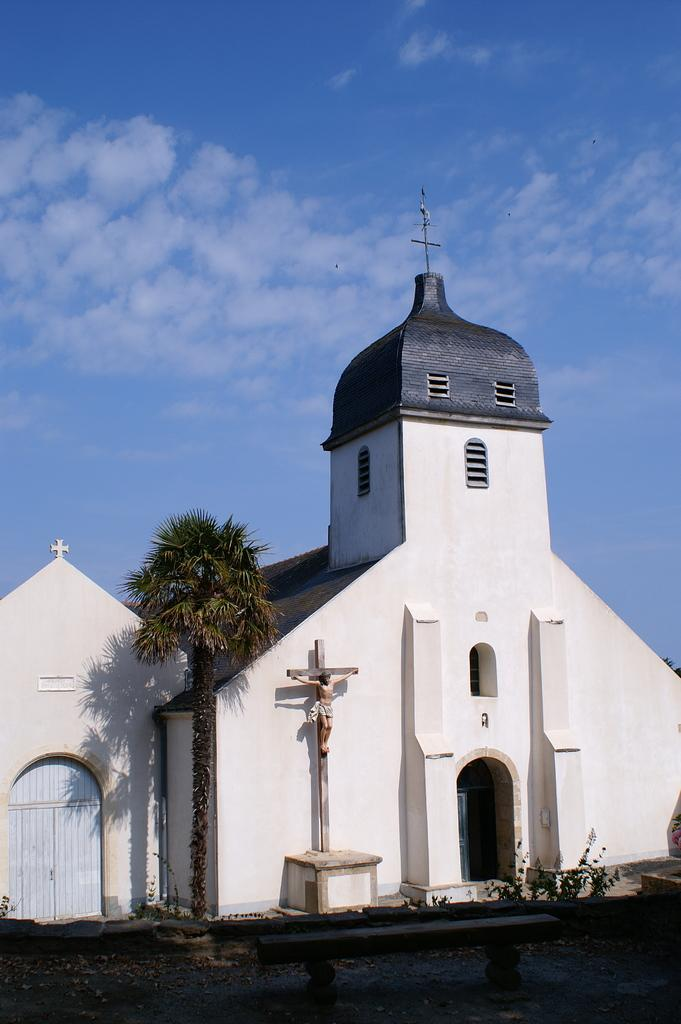What is the main subject of the image? There is a church in the center of the image. Can you describe the church in the image? The church is the main subject, and it is located in the center of the image. Are there any other notable features or objects in the image? The provided facts do not mention any other objects or features in the image. Where is the beggar sitting in the image? There is no beggar present in the image. What color is the roof of the church in the image? The provided facts do not mention the color of the roof. Are there any balloons floating above the church in the image? There is no mention of balloons in the provided facts. 